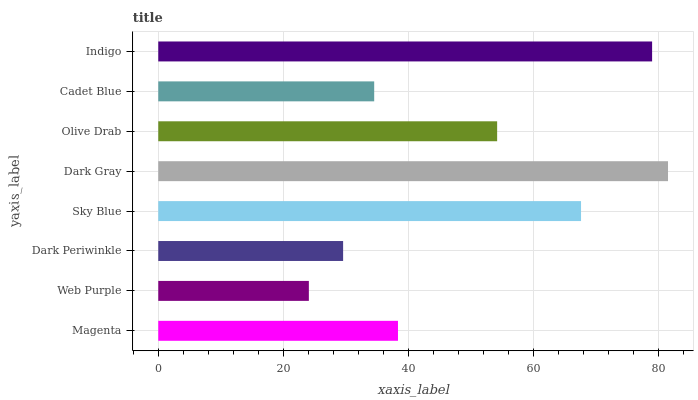Is Web Purple the minimum?
Answer yes or no. Yes. Is Dark Gray the maximum?
Answer yes or no. Yes. Is Dark Periwinkle the minimum?
Answer yes or no. No. Is Dark Periwinkle the maximum?
Answer yes or no. No. Is Dark Periwinkle greater than Web Purple?
Answer yes or no. Yes. Is Web Purple less than Dark Periwinkle?
Answer yes or no. Yes. Is Web Purple greater than Dark Periwinkle?
Answer yes or no. No. Is Dark Periwinkle less than Web Purple?
Answer yes or no. No. Is Olive Drab the high median?
Answer yes or no. Yes. Is Magenta the low median?
Answer yes or no. Yes. Is Indigo the high median?
Answer yes or no. No. Is Cadet Blue the low median?
Answer yes or no. No. 